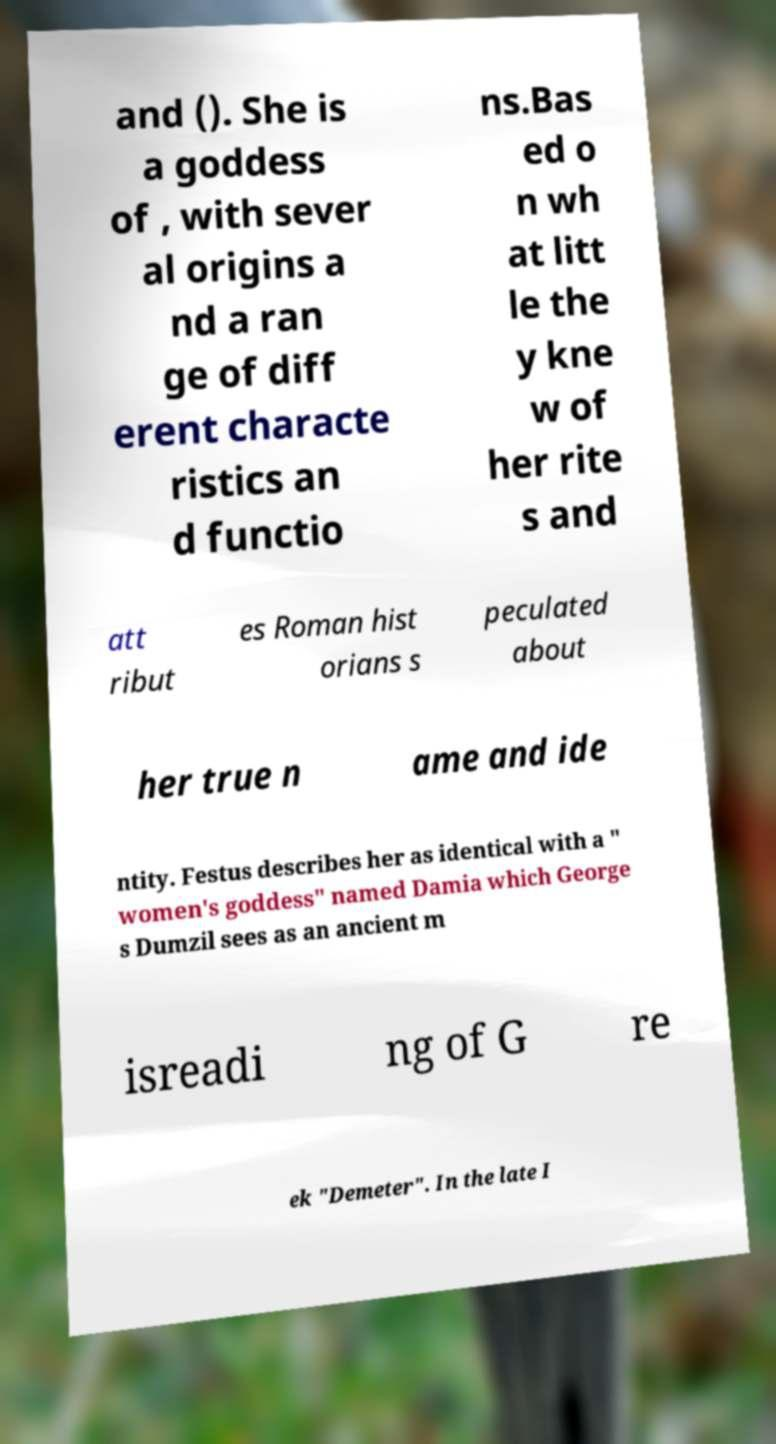For documentation purposes, I need the text within this image transcribed. Could you provide that? and (). She is a goddess of , with sever al origins a nd a ran ge of diff erent characte ristics an d functio ns.Bas ed o n wh at litt le the y kne w of her rite s and att ribut es Roman hist orians s peculated about her true n ame and ide ntity. Festus describes her as identical with a " women's goddess" named Damia which George s Dumzil sees as an ancient m isreadi ng of G re ek "Demeter". In the late I 